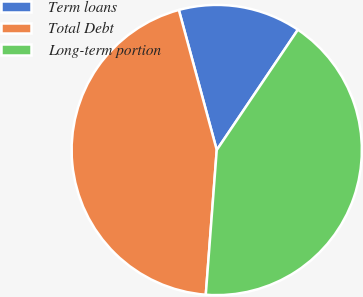Convert chart to OTSL. <chart><loc_0><loc_0><loc_500><loc_500><pie_chart><fcel>Term loans<fcel>Total Debt<fcel>Long-term portion<nl><fcel>13.65%<fcel>44.59%<fcel>41.76%<nl></chart> 